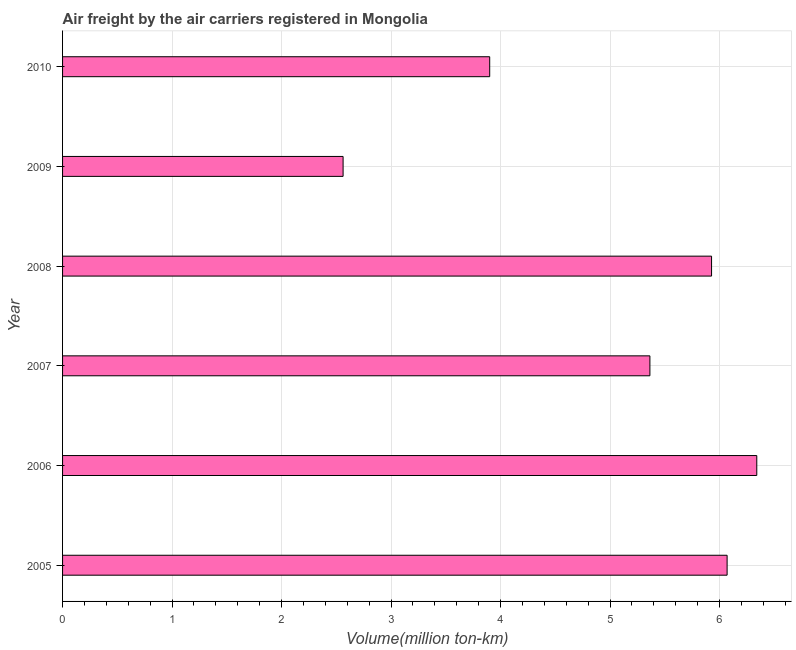Does the graph contain any zero values?
Offer a terse response. No. Does the graph contain grids?
Keep it short and to the point. Yes. What is the title of the graph?
Provide a short and direct response. Air freight by the air carriers registered in Mongolia. What is the label or title of the X-axis?
Provide a short and direct response. Volume(million ton-km). What is the air freight in 2006?
Your answer should be very brief. 6.34. Across all years, what is the maximum air freight?
Keep it short and to the point. 6.34. Across all years, what is the minimum air freight?
Keep it short and to the point. 2.56. In which year was the air freight maximum?
Provide a succinct answer. 2006. What is the sum of the air freight?
Your answer should be compact. 30.16. What is the difference between the air freight in 2008 and 2009?
Give a very brief answer. 3.37. What is the average air freight per year?
Make the answer very short. 5.03. What is the median air freight?
Provide a succinct answer. 5.65. What is the ratio of the air freight in 2006 to that in 2008?
Offer a very short reply. 1.07. Is the difference between the air freight in 2009 and 2010 greater than the difference between any two years?
Your answer should be compact. No. What is the difference between the highest and the second highest air freight?
Provide a short and direct response. 0.27. Is the sum of the air freight in 2008 and 2010 greater than the maximum air freight across all years?
Your answer should be very brief. Yes. What is the difference between the highest and the lowest air freight?
Your answer should be very brief. 3.78. In how many years, is the air freight greater than the average air freight taken over all years?
Your answer should be compact. 4. Are the values on the major ticks of X-axis written in scientific E-notation?
Make the answer very short. No. What is the Volume(million ton-km) in 2005?
Keep it short and to the point. 6.07. What is the Volume(million ton-km) in 2006?
Provide a succinct answer. 6.34. What is the Volume(million ton-km) in 2007?
Your answer should be compact. 5.36. What is the Volume(million ton-km) of 2008?
Provide a short and direct response. 5.93. What is the Volume(million ton-km) of 2009?
Provide a succinct answer. 2.56. What is the Volume(million ton-km) of 2010?
Ensure brevity in your answer.  3.9. What is the difference between the Volume(million ton-km) in 2005 and 2006?
Your answer should be very brief. -0.27. What is the difference between the Volume(million ton-km) in 2005 and 2007?
Offer a terse response. 0.7. What is the difference between the Volume(million ton-km) in 2005 and 2008?
Offer a very short reply. 0.14. What is the difference between the Volume(million ton-km) in 2005 and 2009?
Offer a very short reply. 3.51. What is the difference between the Volume(million ton-km) in 2005 and 2010?
Your response must be concise. 2.17. What is the difference between the Volume(million ton-km) in 2006 and 2007?
Your answer should be compact. 0.98. What is the difference between the Volume(million ton-km) in 2006 and 2008?
Your answer should be compact. 0.41. What is the difference between the Volume(million ton-km) in 2006 and 2009?
Ensure brevity in your answer.  3.78. What is the difference between the Volume(million ton-km) in 2006 and 2010?
Keep it short and to the point. 2.44. What is the difference between the Volume(million ton-km) in 2007 and 2008?
Make the answer very short. -0.56. What is the difference between the Volume(million ton-km) in 2007 and 2009?
Provide a short and direct response. 2.8. What is the difference between the Volume(million ton-km) in 2007 and 2010?
Offer a very short reply. 1.46. What is the difference between the Volume(million ton-km) in 2008 and 2009?
Keep it short and to the point. 3.37. What is the difference between the Volume(million ton-km) in 2008 and 2010?
Provide a succinct answer. 2.03. What is the difference between the Volume(million ton-km) in 2009 and 2010?
Offer a very short reply. -1.34. What is the ratio of the Volume(million ton-km) in 2005 to that in 2007?
Keep it short and to the point. 1.13. What is the ratio of the Volume(million ton-km) in 2005 to that in 2009?
Offer a very short reply. 2.37. What is the ratio of the Volume(million ton-km) in 2005 to that in 2010?
Offer a terse response. 1.56. What is the ratio of the Volume(million ton-km) in 2006 to that in 2007?
Your response must be concise. 1.18. What is the ratio of the Volume(million ton-km) in 2006 to that in 2008?
Ensure brevity in your answer.  1.07. What is the ratio of the Volume(million ton-km) in 2006 to that in 2009?
Your answer should be very brief. 2.48. What is the ratio of the Volume(million ton-km) in 2006 to that in 2010?
Make the answer very short. 1.62. What is the ratio of the Volume(million ton-km) in 2007 to that in 2008?
Ensure brevity in your answer.  0.91. What is the ratio of the Volume(million ton-km) in 2007 to that in 2009?
Keep it short and to the point. 2.09. What is the ratio of the Volume(million ton-km) in 2007 to that in 2010?
Ensure brevity in your answer.  1.38. What is the ratio of the Volume(million ton-km) in 2008 to that in 2009?
Your response must be concise. 2.31. What is the ratio of the Volume(million ton-km) in 2008 to that in 2010?
Offer a very short reply. 1.52. What is the ratio of the Volume(million ton-km) in 2009 to that in 2010?
Ensure brevity in your answer.  0.66. 